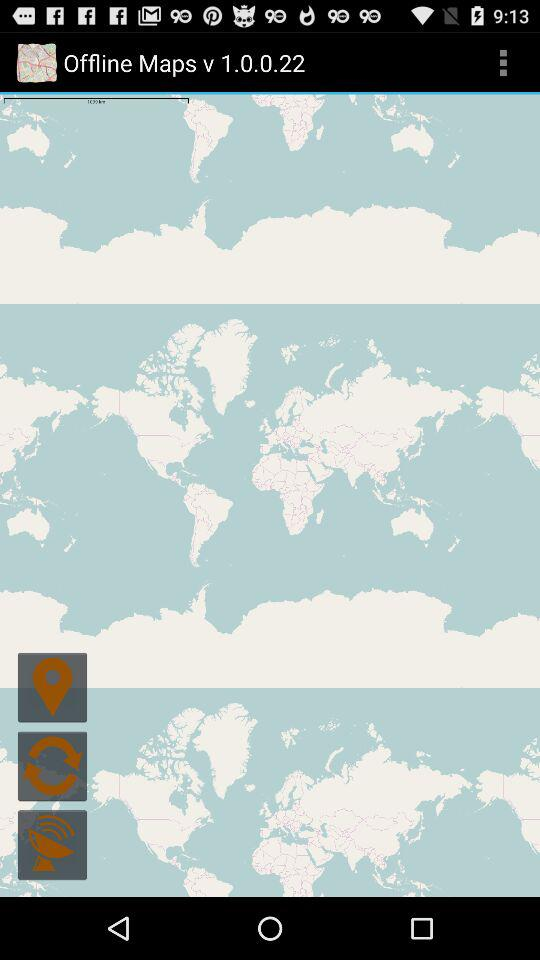What is the application name? The application name is "Offline Maps". 